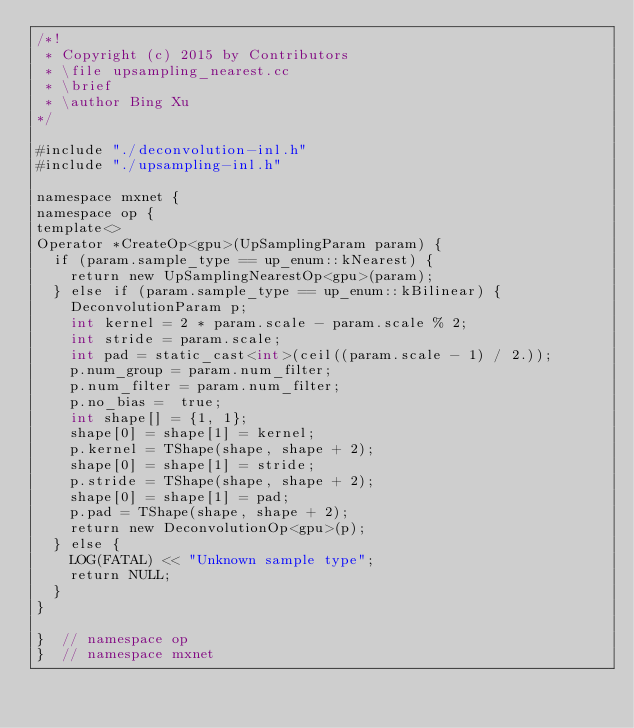<code> <loc_0><loc_0><loc_500><loc_500><_Cuda_>/*!
 * Copyright (c) 2015 by Contributors
 * \file upsampling_nearest.cc
 * \brief
 * \author Bing Xu
*/

#include "./deconvolution-inl.h"
#include "./upsampling-inl.h"

namespace mxnet {
namespace op {
template<>
Operator *CreateOp<gpu>(UpSamplingParam param) {
  if (param.sample_type == up_enum::kNearest) {
    return new UpSamplingNearestOp<gpu>(param);
  } else if (param.sample_type == up_enum::kBilinear) {
    DeconvolutionParam p;
    int kernel = 2 * param.scale - param.scale % 2;
    int stride = param.scale;
    int pad = static_cast<int>(ceil((param.scale - 1) / 2.));
    p.num_group = param.num_filter;
    p.num_filter = param.num_filter;
    p.no_bias =  true;
    int shape[] = {1, 1};
    shape[0] = shape[1] = kernel;
    p.kernel = TShape(shape, shape + 2);
    shape[0] = shape[1] = stride;
    p.stride = TShape(shape, shape + 2);
    shape[0] = shape[1] = pad;
    p.pad = TShape(shape, shape + 2);
    return new DeconvolutionOp<gpu>(p);
  } else {
    LOG(FATAL) << "Unknown sample type";
    return NULL;
  }
}

}  // namespace op
}  // namespace mxnet
</code> 